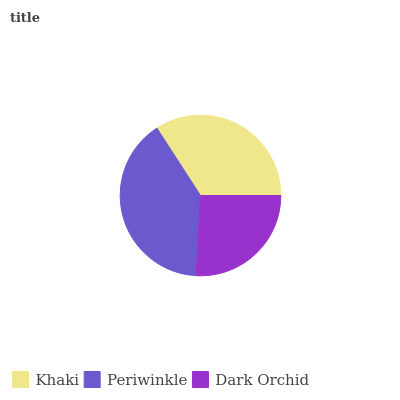Is Dark Orchid the minimum?
Answer yes or no. Yes. Is Periwinkle the maximum?
Answer yes or no. Yes. Is Periwinkle the minimum?
Answer yes or no. No. Is Dark Orchid the maximum?
Answer yes or no. No. Is Periwinkle greater than Dark Orchid?
Answer yes or no. Yes. Is Dark Orchid less than Periwinkle?
Answer yes or no. Yes. Is Dark Orchid greater than Periwinkle?
Answer yes or no. No. Is Periwinkle less than Dark Orchid?
Answer yes or no. No. Is Khaki the high median?
Answer yes or no. Yes. Is Khaki the low median?
Answer yes or no. Yes. Is Periwinkle the high median?
Answer yes or no. No. Is Dark Orchid the low median?
Answer yes or no. No. 